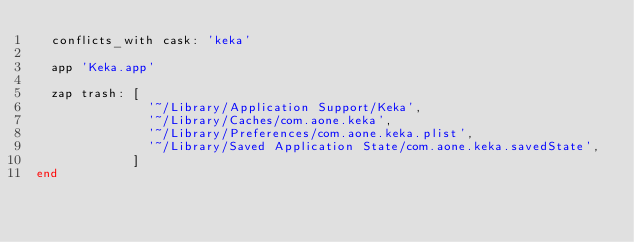Convert code to text. <code><loc_0><loc_0><loc_500><loc_500><_Ruby_>  conflicts_with cask: 'keka'

  app 'Keka.app'

  zap trash: [
               '~/Library/Application Support/Keka',
               '~/Library/Caches/com.aone.keka',
               '~/Library/Preferences/com.aone.keka.plist',
               '~/Library/Saved Application State/com.aone.keka.savedState',
             ]
end
</code> 